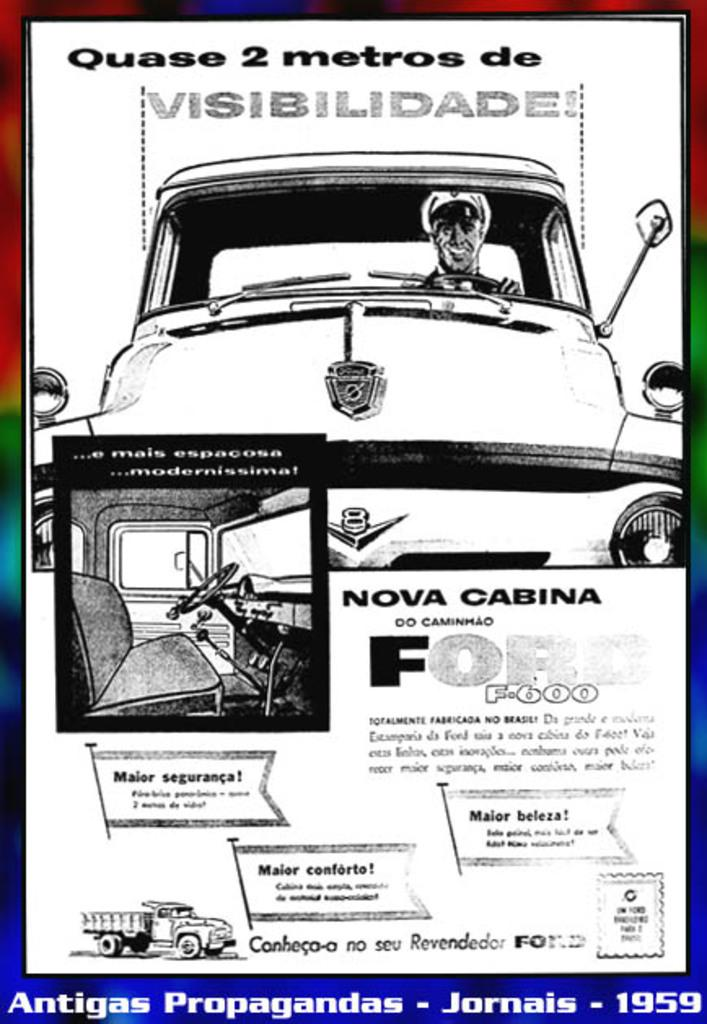What is the main object in the image? There is a brochure in the image. What activity is being depicted in the image? There is a person riding a car in the image. What other vehicle is present in the image? There is a truck in the image. Can you describe any text or writing in the image? There is writing on one or more of the objects in the image. What type of story is the person telling while jumping in the image? There is no person jumping in the image, and no story is being told. 